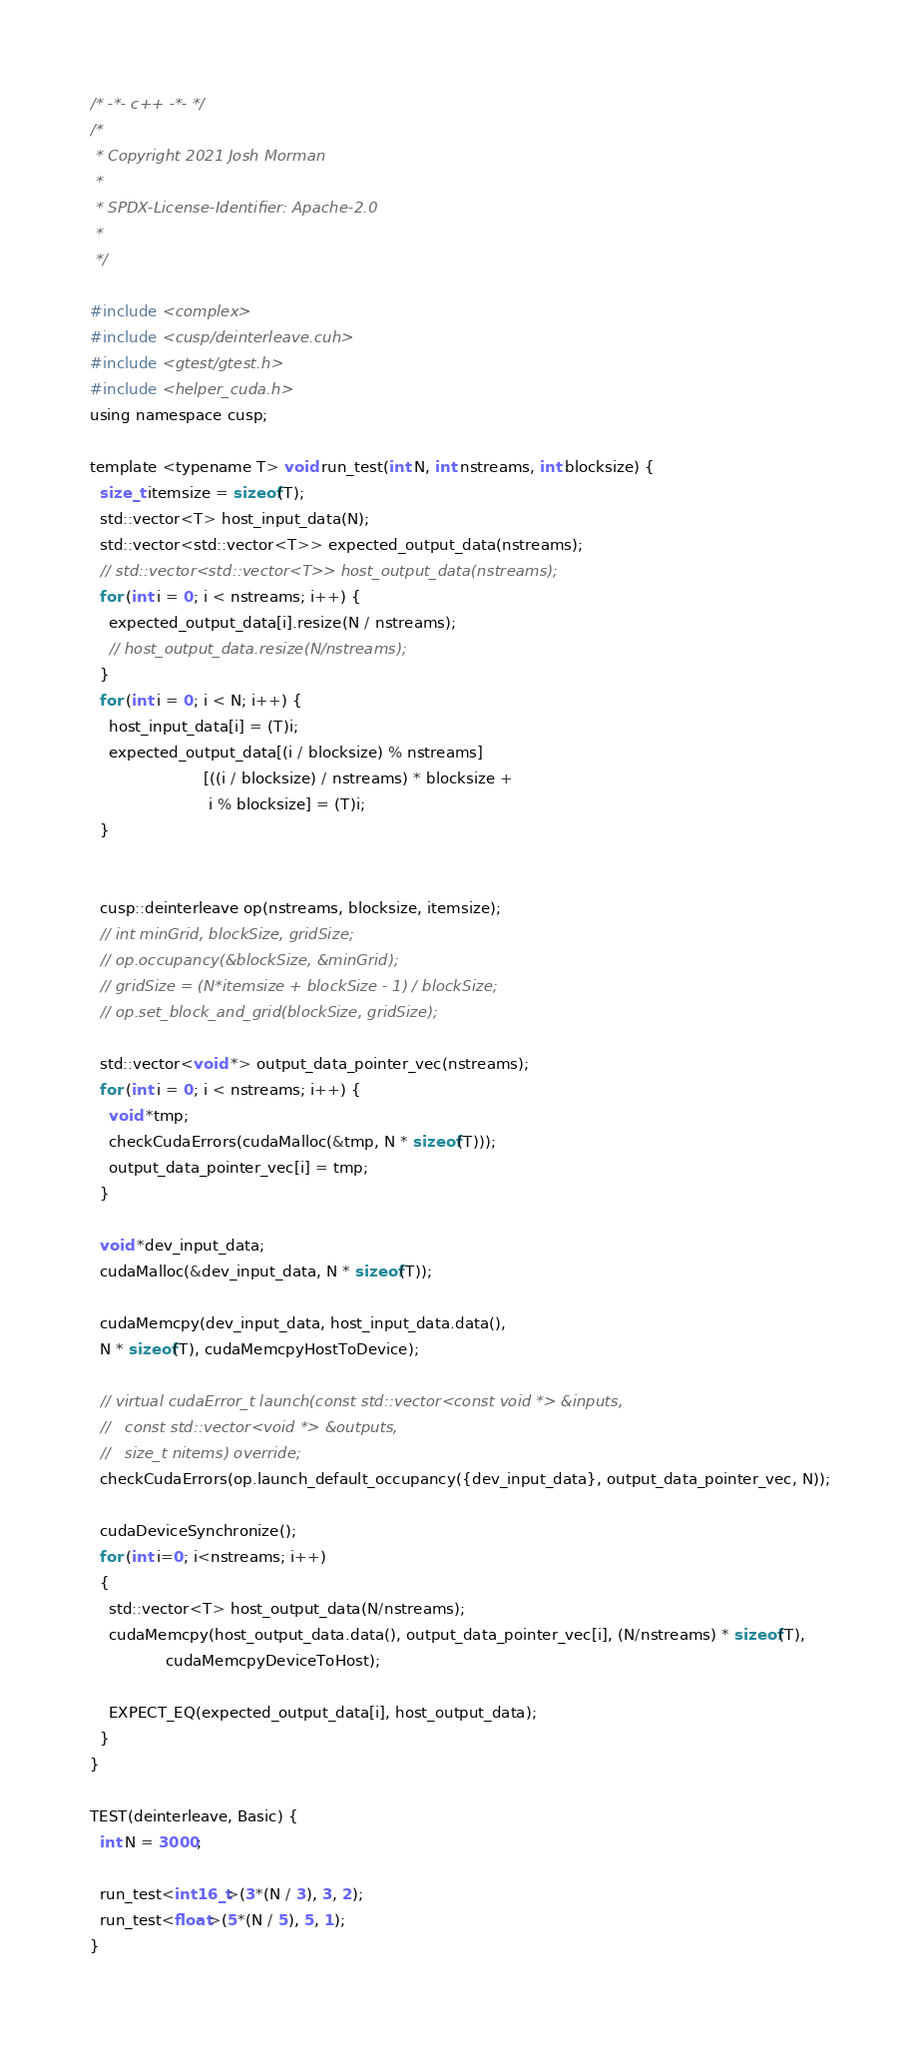Convert code to text. <code><loc_0><loc_0><loc_500><loc_500><_Cuda_>/* -*- c++ -*- */
/*
 * Copyright 2021 Josh Morman
 *
 * SPDX-License-Identifier: Apache-2.0
 *
 */

#include <complex>
#include <cusp/deinterleave.cuh>
#include <gtest/gtest.h>
#include <helper_cuda.h>
using namespace cusp;

template <typename T> void run_test(int N, int nstreams, int blocksize) {
  size_t itemsize = sizeof(T);
  std::vector<T> host_input_data(N);
  std::vector<std::vector<T>> expected_output_data(nstreams);
  // std::vector<std::vector<T>> host_output_data(nstreams);
  for (int i = 0; i < nstreams; i++) {
    expected_output_data[i].resize(N / nstreams);
    // host_output_data.resize(N/nstreams);
  }
  for (int i = 0; i < N; i++) {
    host_input_data[i] = (T)i;
    expected_output_data[(i / blocksize) % nstreams]
                        [((i / blocksize) / nstreams) * blocksize +
                         i % blocksize] = (T)i;
  }


  cusp::deinterleave op(nstreams, blocksize, itemsize);
  // int minGrid, blockSize, gridSize;
  // op.occupancy(&blockSize, &minGrid);
  // gridSize = (N*itemsize + blockSize - 1) / blockSize;
  // op.set_block_and_grid(blockSize, gridSize);

  std::vector<void *> output_data_pointer_vec(nstreams);
  for (int i = 0; i < nstreams; i++) {
    void *tmp;
    checkCudaErrors(cudaMalloc(&tmp, N * sizeof(T)));
    output_data_pointer_vec[i] = tmp;
  }

  void *dev_input_data;
  cudaMalloc(&dev_input_data, N * sizeof(T));

  cudaMemcpy(dev_input_data, host_input_data.data(),
  N * sizeof(T), cudaMemcpyHostToDevice);

  // virtual cudaError_t launch(const std::vector<const void *> &inputs,
  //   const std::vector<void *> &outputs,
  //   size_t nitems) override;
  checkCudaErrors(op.launch_default_occupancy({dev_input_data}, output_data_pointer_vec, N));

  cudaDeviceSynchronize();
  for (int i=0; i<nstreams; i++)
  {
    std::vector<T> host_output_data(N/nstreams);
    cudaMemcpy(host_output_data.data(), output_data_pointer_vec[i], (N/nstreams) * sizeof(T),
                cudaMemcpyDeviceToHost);

    EXPECT_EQ(expected_output_data[i], host_output_data);
  }
}

TEST(deinterleave, Basic) {
  int N = 3000;

  run_test<int16_t>(3*(N / 3), 3, 2);
  run_test<float>(5*(N / 5), 5, 1);
}</code> 